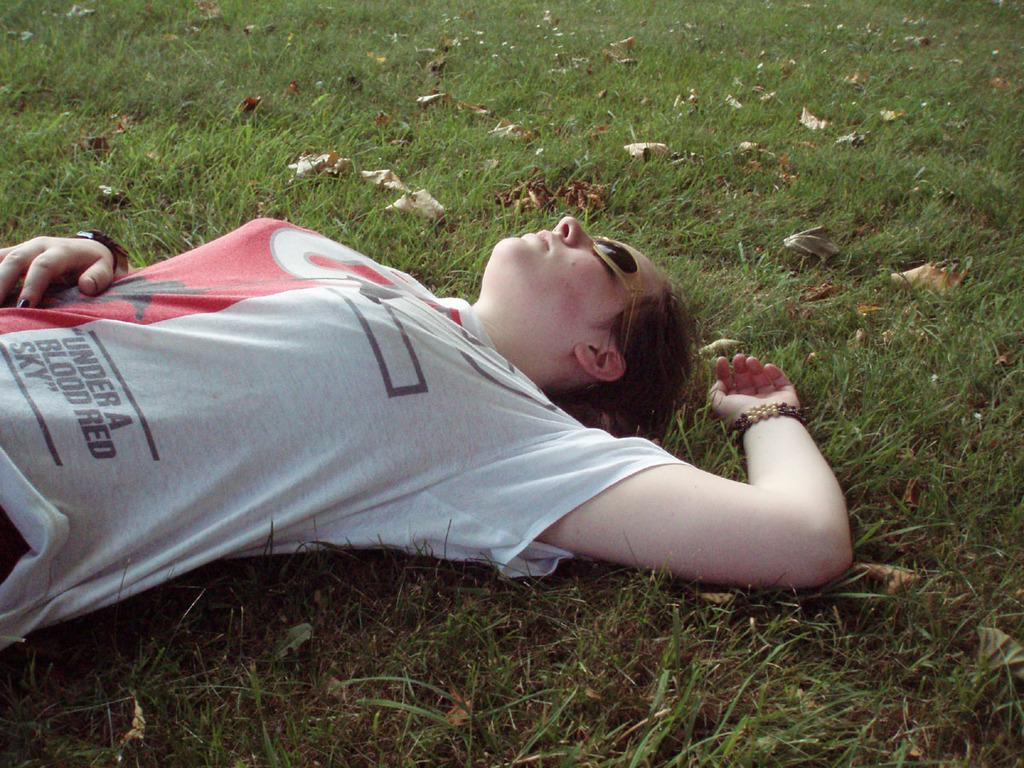Who is present in the image? There is a woman in the image. What is the woman doing in the image? The woman is lying on the grass. What can be seen on the grass in the image? There are dry leaves on the grass in the image. Reasoning: Let'g: Let's think step by step in order to produce the conversation. We start by identifying the main subject in the image, which is the woman. Then, we describe her position and activity, which is lying on the grass. Finally, we mention the additional detail of the dry leaves on the grass. Each question is designed to elicit a specific detail about the image that is known from the provided facts. Absurd Question/Answer: What type of quince is being used as a pillow for the woman in the image? There is no quince present in the image; the woman is lying on the grass with dry leaves. Can you tell me how many berries are scattered around the woman in the image? There are no berries present in the image; only the woman, grass, and dry leaves can be seen. 